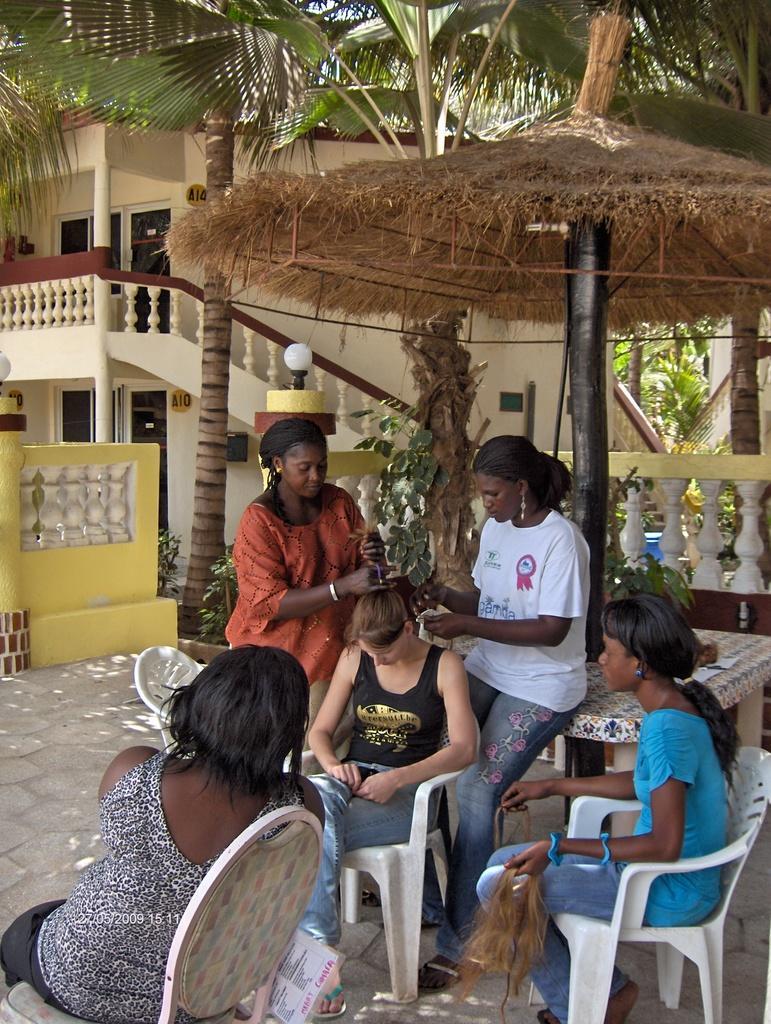Describe this image in one or two sentences. In the image we can see there are people who are sitting and others are standing. At the back there is a building. 